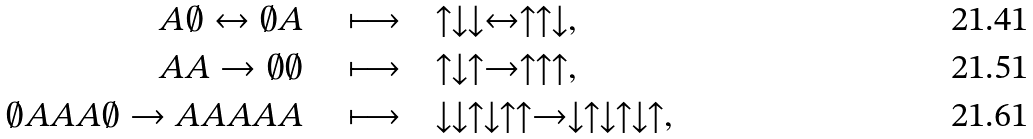<formula> <loc_0><loc_0><loc_500><loc_500>A \emptyset \leftrightarrow \emptyset A \quad & \longmapsto \quad \uparrow \downarrow \downarrow \leftrightarrow \uparrow \uparrow \downarrow , \\ A A \rightarrow \emptyset \emptyset \quad & \longmapsto \quad \uparrow \downarrow \uparrow \rightarrow \uparrow \uparrow \uparrow , \\ \emptyset A A A \emptyset \rightarrow A A A A A \quad & \longmapsto \quad \downarrow \downarrow \uparrow \downarrow \uparrow \uparrow \rightarrow \downarrow \uparrow \downarrow \uparrow \downarrow \uparrow ,</formula> 